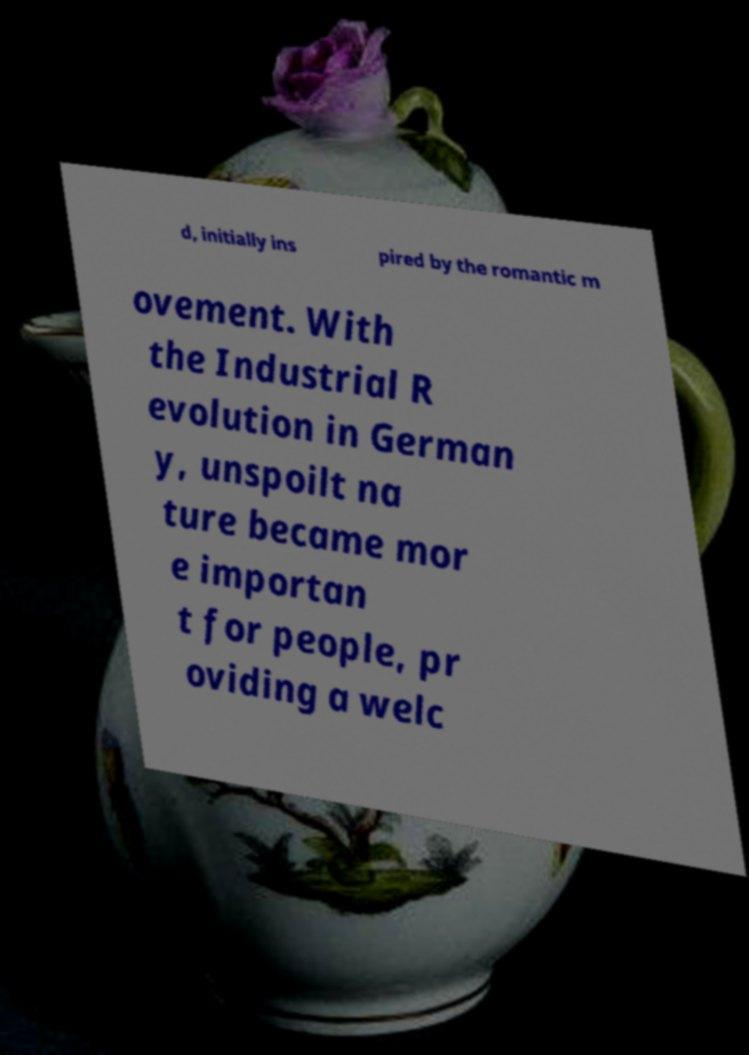What messages or text are displayed in this image? I need them in a readable, typed format. d, initially ins pired by the romantic m ovement. With the Industrial R evolution in German y, unspoilt na ture became mor e importan t for people, pr oviding a welc 